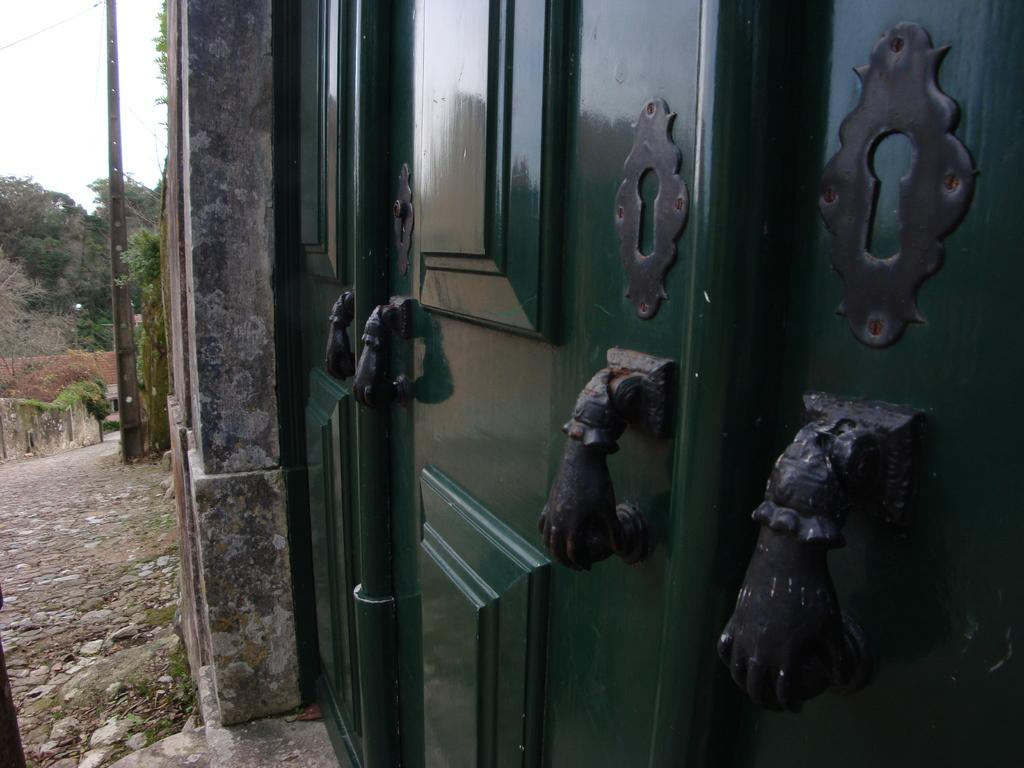What type of structure can be seen in the image? There is a door in the image. What type of natural elements are present in the image? There are stones, grass, trees, and the sky visible in the image. What man-made object can be seen in the image? There is a pole in the image. How many laborers are working on the kite in the image? There is no kite or laborers present in the image. What type of boundary is depicted in the image? There is no boundary depicted in the image. 